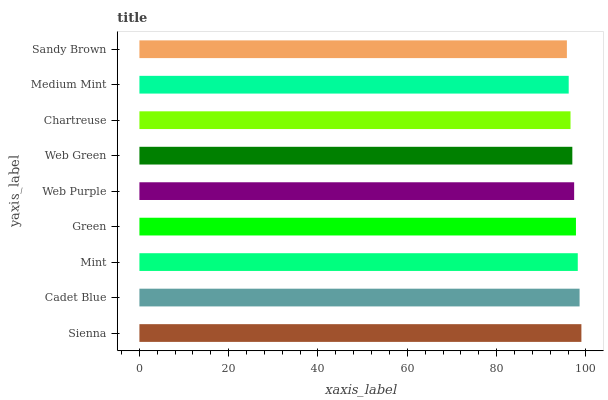Is Sandy Brown the minimum?
Answer yes or no. Yes. Is Sienna the maximum?
Answer yes or no. Yes. Is Cadet Blue the minimum?
Answer yes or no. No. Is Cadet Blue the maximum?
Answer yes or no. No. Is Sienna greater than Cadet Blue?
Answer yes or no. Yes. Is Cadet Blue less than Sienna?
Answer yes or no. Yes. Is Cadet Blue greater than Sienna?
Answer yes or no. No. Is Sienna less than Cadet Blue?
Answer yes or no. No. Is Web Purple the high median?
Answer yes or no. Yes. Is Web Purple the low median?
Answer yes or no. Yes. Is Green the high median?
Answer yes or no. No. Is Sienna the low median?
Answer yes or no. No. 